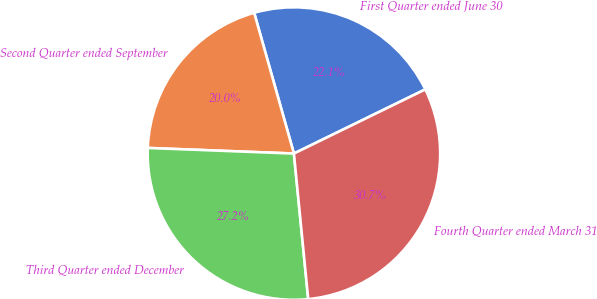<chart> <loc_0><loc_0><loc_500><loc_500><pie_chart><fcel>First Quarter ended June 30<fcel>Second Quarter ended September<fcel>Third Quarter ended December<fcel>Fourth Quarter ended March 31<nl><fcel>22.15%<fcel>20.01%<fcel>27.17%<fcel>30.67%<nl></chart> 